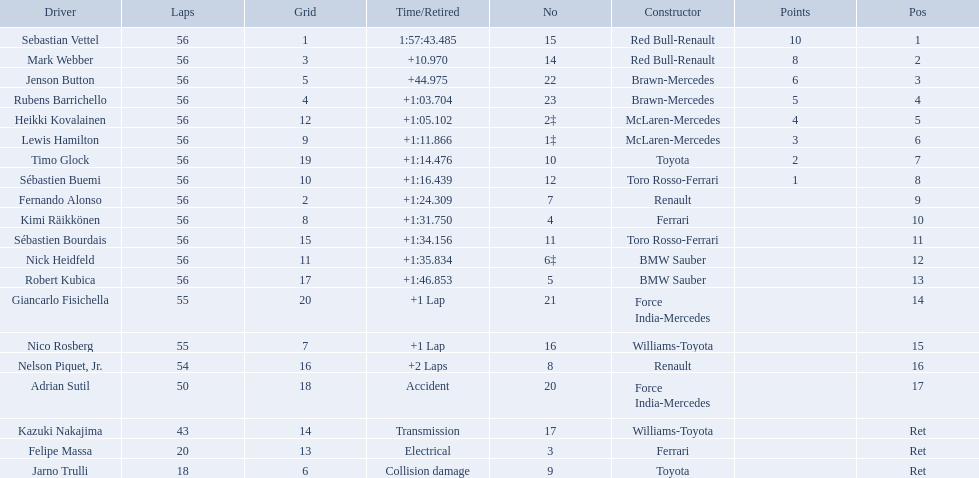Could you parse the entire table? {'header': ['Driver', 'Laps', 'Grid', 'Time/Retired', 'No', 'Constructor', 'Points', 'Pos'], 'rows': [['Sebastian Vettel', '56', '1', '1:57:43.485', '15', 'Red Bull-Renault', '10', '1'], ['Mark Webber', '56', '3', '+10.970', '14', 'Red Bull-Renault', '8', '2'], ['Jenson Button', '56', '5', '+44.975', '22', 'Brawn-Mercedes', '6', '3'], ['Rubens Barrichello', '56', '4', '+1:03.704', '23', 'Brawn-Mercedes', '5', '4'], ['Heikki Kovalainen', '56', '12', '+1:05.102', '2‡', 'McLaren-Mercedes', '4', '5'], ['Lewis Hamilton', '56', '9', '+1:11.866', '1‡', 'McLaren-Mercedes', '3', '6'], ['Timo Glock', '56', '19', '+1:14.476', '10', 'Toyota', '2', '7'], ['Sébastien Buemi', '56', '10', '+1:16.439', '12', 'Toro Rosso-Ferrari', '1', '8'], ['Fernando Alonso', '56', '2', '+1:24.309', '7', 'Renault', '', '9'], ['Kimi Räikkönen', '56', '8', '+1:31.750', '4', 'Ferrari', '', '10'], ['Sébastien Bourdais', '56', '15', '+1:34.156', '11', 'Toro Rosso-Ferrari', '', '11'], ['Nick Heidfeld', '56', '11', '+1:35.834', '6‡', 'BMW Sauber', '', '12'], ['Robert Kubica', '56', '17', '+1:46.853', '5', 'BMW Sauber', '', '13'], ['Giancarlo Fisichella', '55', '20', '+1 Lap', '21', 'Force India-Mercedes', '', '14'], ['Nico Rosberg', '55', '7', '+1 Lap', '16', 'Williams-Toyota', '', '15'], ['Nelson Piquet, Jr.', '54', '16', '+2 Laps', '8', 'Renault', '', '16'], ['Adrian Sutil', '50', '18', 'Accident', '20', 'Force India-Mercedes', '', '17'], ['Kazuki Nakajima', '43', '14', 'Transmission', '17', 'Williams-Toyota', '', 'Ret'], ['Felipe Massa', '20', '13', 'Electrical', '3', 'Ferrari', '', 'Ret'], ['Jarno Trulli', '18', '6', 'Collision damage', '9', 'Toyota', '', 'Ret']]} Who were the drivers at the 2009 chinese grand prix? Sebastian Vettel, Mark Webber, Jenson Button, Rubens Barrichello, Heikki Kovalainen, Lewis Hamilton, Timo Glock, Sébastien Buemi, Fernando Alonso, Kimi Räikkönen, Sébastien Bourdais, Nick Heidfeld, Robert Kubica, Giancarlo Fisichella, Nico Rosberg, Nelson Piquet, Jr., Adrian Sutil, Kazuki Nakajima, Felipe Massa, Jarno Trulli. Who had the slowest time? Robert Kubica. 